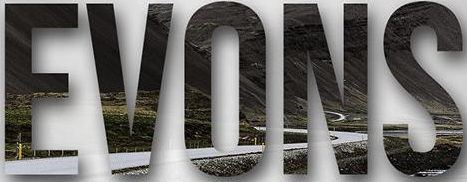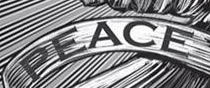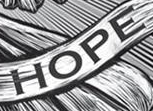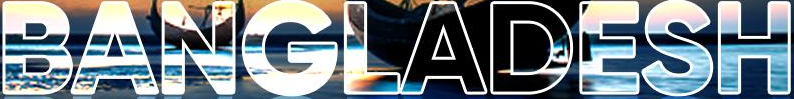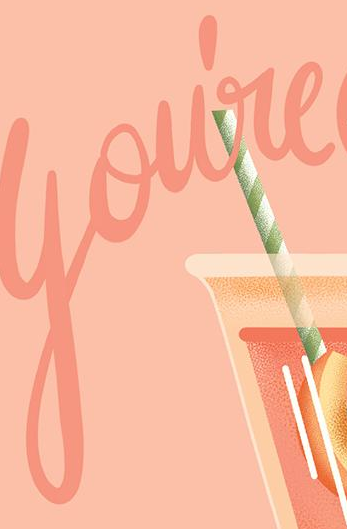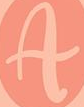What words can you see in these images in sequence, separated by a semicolon? EVONS; PEACE; HOPE; BANGLADESH; You're; A 